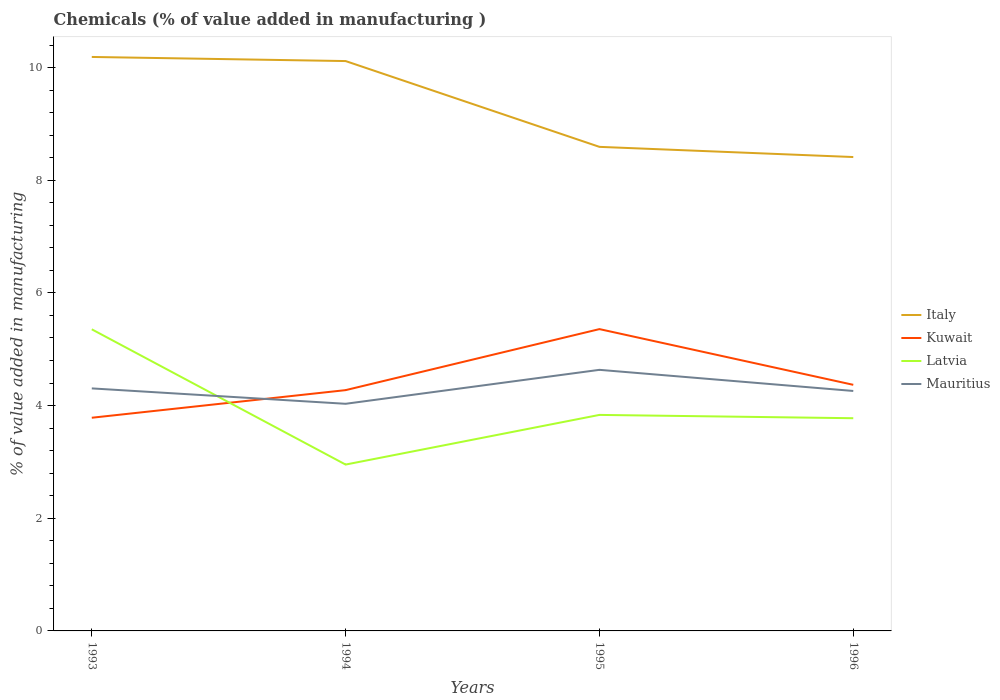Across all years, what is the maximum value added in manufacturing chemicals in Kuwait?
Give a very brief answer. 3.78. In which year was the value added in manufacturing chemicals in Mauritius maximum?
Your answer should be very brief. 1994. What is the total value added in manufacturing chemicals in Italy in the graph?
Make the answer very short. 1.78. What is the difference between the highest and the second highest value added in manufacturing chemicals in Mauritius?
Your response must be concise. 0.6. What is the difference between the highest and the lowest value added in manufacturing chemicals in Italy?
Provide a succinct answer. 2. How many lines are there?
Give a very brief answer. 4. Does the graph contain any zero values?
Give a very brief answer. No. Does the graph contain grids?
Ensure brevity in your answer.  No. How many legend labels are there?
Your response must be concise. 4. How are the legend labels stacked?
Provide a short and direct response. Vertical. What is the title of the graph?
Ensure brevity in your answer.  Chemicals (% of value added in manufacturing ). What is the label or title of the X-axis?
Keep it short and to the point. Years. What is the label or title of the Y-axis?
Your response must be concise. % of value added in manufacturing. What is the % of value added in manufacturing in Italy in 1993?
Offer a terse response. 10.19. What is the % of value added in manufacturing of Kuwait in 1993?
Make the answer very short. 3.78. What is the % of value added in manufacturing of Latvia in 1993?
Your response must be concise. 5.35. What is the % of value added in manufacturing of Mauritius in 1993?
Your response must be concise. 4.31. What is the % of value added in manufacturing of Italy in 1994?
Ensure brevity in your answer.  10.12. What is the % of value added in manufacturing in Kuwait in 1994?
Provide a short and direct response. 4.27. What is the % of value added in manufacturing of Latvia in 1994?
Give a very brief answer. 2.95. What is the % of value added in manufacturing in Mauritius in 1994?
Keep it short and to the point. 4.03. What is the % of value added in manufacturing of Italy in 1995?
Ensure brevity in your answer.  8.59. What is the % of value added in manufacturing in Kuwait in 1995?
Give a very brief answer. 5.36. What is the % of value added in manufacturing in Latvia in 1995?
Provide a short and direct response. 3.83. What is the % of value added in manufacturing of Mauritius in 1995?
Provide a succinct answer. 4.63. What is the % of value added in manufacturing in Italy in 1996?
Your response must be concise. 8.41. What is the % of value added in manufacturing in Kuwait in 1996?
Provide a short and direct response. 4.37. What is the % of value added in manufacturing of Latvia in 1996?
Give a very brief answer. 3.78. What is the % of value added in manufacturing in Mauritius in 1996?
Provide a succinct answer. 4.26. Across all years, what is the maximum % of value added in manufacturing in Italy?
Make the answer very short. 10.19. Across all years, what is the maximum % of value added in manufacturing in Kuwait?
Your response must be concise. 5.36. Across all years, what is the maximum % of value added in manufacturing of Latvia?
Offer a very short reply. 5.35. Across all years, what is the maximum % of value added in manufacturing of Mauritius?
Your answer should be very brief. 4.63. Across all years, what is the minimum % of value added in manufacturing in Italy?
Your response must be concise. 8.41. Across all years, what is the minimum % of value added in manufacturing in Kuwait?
Your answer should be compact. 3.78. Across all years, what is the minimum % of value added in manufacturing in Latvia?
Provide a succinct answer. 2.95. Across all years, what is the minimum % of value added in manufacturing of Mauritius?
Provide a short and direct response. 4.03. What is the total % of value added in manufacturing of Italy in the graph?
Offer a very short reply. 37.31. What is the total % of value added in manufacturing in Kuwait in the graph?
Make the answer very short. 17.79. What is the total % of value added in manufacturing in Latvia in the graph?
Offer a terse response. 15.92. What is the total % of value added in manufacturing of Mauritius in the graph?
Make the answer very short. 17.23. What is the difference between the % of value added in manufacturing in Italy in 1993 and that in 1994?
Make the answer very short. 0.07. What is the difference between the % of value added in manufacturing in Kuwait in 1993 and that in 1994?
Offer a terse response. -0.49. What is the difference between the % of value added in manufacturing of Latvia in 1993 and that in 1994?
Your answer should be very brief. 2.4. What is the difference between the % of value added in manufacturing in Mauritius in 1993 and that in 1994?
Make the answer very short. 0.27. What is the difference between the % of value added in manufacturing in Italy in 1993 and that in 1995?
Offer a terse response. 1.6. What is the difference between the % of value added in manufacturing of Kuwait in 1993 and that in 1995?
Your response must be concise. -1.57. What is the difference between the % of value added in manufacturing of Latvia in 1993 and that in 1995?
Provide a succinct answer. 1.52. What is the difference between the % of value added in manufacturing of Mauritius in 1993 and that in 1995?
Give a very brief answer. -0.33. What is the difference between the % of value added in manufacturing of Italy in 1993 and that in 1996?
Give a very brief answer. 1.78. What is the difference between the % of value added in manufacturing in Kuwait in 1993 and that in 1996?
Provide a succinct answer. -0.58. What is the difference between the % of value added in manufacturing of Latvia in 1993 and that in 1996?
Provide a short and direct response. 1.58. What is the difference between the % of value added in manufacturing of Mauritius in 1993 and that in 1996?
Ensure brevity in your answer.  0.05. What is the difference between the % of value added in manufacturing in Italy in 1994 and that in 1995?
Keep it short and to the point. 1.52. What is the difference between the % of value added in manufacturing in Kuwait in 1994 and that in 1995?
Provide a short and direct response. -1.08. What is the difference between the % of value added in manufacturing in Latvia in 1994 and that in 1995?
Ensure brevity in your answer.  -0.88. What is the difference between the % of value added in manufacturing of Mauritius in 1994 and that in 1995?
Offer a very short reply. -0.6. What is the difference between the % of value added in manufacturing in Italy in 1994 and that in 1996?
Give a very brief answer. 1.7. What is the difference between the % of value added in manufacturing of Kuwait in 1994 and that in 1996?
Give a very brief answer. -0.09. What is the difference between the % of value added in manufacturing in Latvia in 1994 and that in 1996?
Offer a very short reply. -0.82. What is the difference between the % of value added in manufacturing of Mauritius in 1994 and that in 1996?
Your answer should be compact. -0.23. What is the difference between the % of value added in manufacturing in Italy in 1995 and that in 1996?
Provide a short and direct response. 0.18. What is the difference between the % of value added in manufacturing of Kuwait in 1995 and that in 1996?
Provide a succinct answer. 0.99. What is the difference between the % of value added in manufacturing of Latvia in 1995 and that in 1996?
Your answer should be very brief. 0.06. What is the difference between the % of value added in manufacturing in Mauritius in 1995 and that in 1996?
Provide a short and direct response. 0.37. What is the difference between the % of value added in manufacturing in Italy in 1993 and the % of value added in manufacturing in Kuwait in 1994?
Give a very brief answer. 5.91. What is the difference between the % of value added in manufacturing in Italy in 1993 and the % of value added in manufacturing in Latvia in 1994?
Your response must be concise. 7.24. What is the difference between the % of value added in manufacturing in Italy in 1993 and the % of value added in manufacturing in Mauritius in 1994?
Ensure brevity in your answer.  6.16. What is the difference between the % of value added in manufacturing in Kuwait in 1993 and the % of value added in manufacturing in Latvia in 1994?
Offer a terse response. 0.83. What is the difference between the % of value added in manufacturing of Kuwait in 1993 and the % of value added in manufacturing of Mauritius in 1994?
Give a very brief answer. -0.25. What is the difference between the % of value added in manufacturing in Latvia in 1993 and the % of value added in manufacturing in Mauritius in 1994?
Provide a short and direct response. 1.32. What is the difference between the % of value added in manufacturing in Italy in 1993 and the % of value added in manufacturing in Kuwait in 1995?
Offer a terse response. 4.83. What is the difference between the % of value added in manufacturing in Italy in 1993 and the % of value added in manufacturing in Latvia in 1995?
Your answer should be very brief. 6.35. What is the difference between the % of value added in manufacturing of Italy in 1993 and the % of value added in manufacturing of Mauritius in 1995?
Provide a short and direct response. 5.55. What is the difference between the % of value added in manufacturing in Kuwait in 1993 and the % of value added in manufacturing in Latvia in 1995?
Keep it short and to the point. -0.05. What is the difference between the % of value added in manufacturing of Kuwait in 1993 and the % of value added in manufacturing of Mauritius in 1995?
Offer a very short reply. -0.85. What is the difference between the % of value added in manufacturing in Latvia in 1993 and the % of value added in manufacturing in Mauritius in 1995?
Your answer should be compact. 0.72. What is the difference between the % of value added in manufacturing in Italy in 1993 and the % of value added in manufacturing in Kuwait in 1996?
Give a very brief answer. 5.82. What is the difference between the % of value added in manufacturing of Italy in 1993 and the % of value added in manufacturing of Latvia in 1996?
Provide a short and direct response. 6.41. What is the difference between the % of value added in manufacturing in Italy in 1993 and the % of value added in manufacturing in Mauritius in 1996?
Keep it short and to the point. 5.93. What is the difference between the % of value added in manufacturing in Kuwait in 1993 and the % of value added in manufacturing in Latvia in 1996?
Provide a succinct answer. 0.01. What is the difference between the % of value added in manufacturing of Kuwait in 1993 and the % of value added in manufacturing of Mauritius in 1996?
Offer a terse response. -0.48. What is the difference between the % of value added in manufacturing in Latvia in 1993 and the % of value added in manufacturing in Mauritius in 1996?
Provide a succinct answer. 1.09. What is the difference between the % of value added in manufacturing of Italy in 1994 and the % of value added in manufacturing of Kuwait in 1995?
Your answer should be very brief. 4.76. What is the difference between the % of value added in manufacturing of Italy in 1994 and the % of value added in manufacturing of Latvia in 1995?
Provide a short and direct response. 6.28. What is the difference between the % of value added in manufacturing in Italy in 1994 and the % of value added in manufacturing in Mauritius in 1995?
Offer a very short reply. 5.48. What is the difference between the % of value added in manufacturing of Kuwait in 1994 and the % of value added in manufacturing of Latvia in 1995?
Ensure brevity in your answer.  0.44. What is the difference between the % of value added in manufacturing in Kuwait in 1994 and the % of value added in manufacturing in Mauritius in 1995?
Your response must be concise. -0.36. What is the difference between the % of value added in manufacturing in Latvia in 1994 and the % of value added in manufacturing in Mauritius in 1995?
Provide a succinct answer. -1.68. What is the difference between the % of value added in manufacturing in Italy in 1994 and the % of value added in manufacturing in Kuwait in 1996?
Offer a very short reply. 5.75. What is the difference between the % of value added in manufacturing in Italy in 1994 and the % of value added in manufacturing in Latvia in 1996?
Provide a succinct answer. 6.34. What is the difference between the % of value added in manufacturing in Italy in 1994 and the % of value added in manufacturing in Mauritius in 1996?
Offer a very short reply. 5.86. What is the difference between the % of value added in manufacturing in Kuwait in 1994 and the % of value added in manufacturing in Latvia in 1996?
Provide a succinct answer. 0.5. What is the difference between the % of value added in manufacturing in Kuwait in 1994 and the % of value added in manufacturing in Mauritius in 1996?
Make the answer very short. 0.01. What is the difference between the % of value added in manufacturing of Latvia in 1994 and the % of value added in manufacturing of Mauritius in 1996?
Provide a succinct answer. -1.31. What is the difference between the % of value added in manufacturing of Italy in 1995 and the % of value added in manufacturing of Kuwait in 1996?
Ensure brevity in your answer.  4.22. What is the difference between the % of value added in manufacturing in Italy in 1995 and the % of value added in manufacturing in Latvia in 1996?
Provide a succinct answer. 4.82. What is the difference between the % of value added in manufacturing of Italy in 1995 and the % of value added in manufacturing of Mauritius in 1996?
Provide a succinct answer. 4.33. What is the difference between the % of value added in manufacturing of Kuwait in 1995 and the % of value added in manufacturing of Latvia in 1996?
Your answer should be compact. 1.58. What is the difference between the % of value added in manufacturing of Kuwait in 1995 and the % of value added in manufacturing of Mauritius in 1996?
Your answer should be very brief. 1.1. What is the difference between the % of value added in manufacturing in Latvia in 1995 and the % of value added in manufacturing in Mauritius in 1996?
Keep it short and to the point. -0.42. What is the average % of value added in manufacturing of Italy per year?
Your answer should be compact. 9.33. What is the average % of value added in manufacturing of Kuwait per year?
Provide a short and direct response. 4.45. What is the average % of value added in manufacturing of Latvia per year?
Offer a terse response. 3.98. What is the average % of value added in manufacturing in Mauritius per year?
Offer a terse response. 4.31. In the year 1993, what is the difference between the % of value added in manufacturing of Italy and % of value added in manufacturing of Kuwait?
Offer a terse response. 6.4. In the year 1993, what is the difference between the % of value added in manufacturing in Italy and % of value added in manufacturing in Latvia?
Offer a very short reply. 4.83. In the year 1993, what is the difference between the % of value added in manufacturing of Italy and % of value added in manufacturing of Mauritius?
Keep it short and to the point. 5.88. In the year 1993, what is the difference between the % of value added in manufacturing in Kuwait and % of value added in manufacturing in Latvia?
Ensure brevity in your answer.  -1.57. In the year 1993, what is the difference between the % of value added in manufacturing in Kuwait and % of value added in manufacturing in Mauritius?
Your response must be concise. -0.52. In the year 1993, what is the difference between the % of value added in manufacturing of Latvia and % of value added in manufacturing of Mauritius?
Give a very brief answer. 1.05. In the year 1994, what is the difference between the % of value added in manufacturing in Italy and % of value added in manufacturing in Kuwait?
Offer a very short reply. 5.84. In the year 1994, what is the difference between the % of value added in manufacturing in Italy and % of value added in manufacturing in Latvia?
Your answer should be compact. 7.16. In the year 1994, what is the difference between the % of value added in manufacturing in Italy and % of value added in manufacturing in Mauritius?
Your response must be concise. 6.08. In the year 1994, what is the difference between the % of value added in manufacturing of Kuwait and % of value added in manufacturing of Latvia?
Provide a succinct answer. 1.32. In the year 1994, what is the difference between the % of value added in manufacturing in Kuwait and % of value added in manufacturing in Mauritius?
Provide a short and direct response. 0.24. In the year 1994, what is the difference between the % of value added in manufacturing of Latvia and % of value added in manufacturing of Mauritius?
Provide a short and direct response. -1.08. In the year 1995, what is the difference between the % of value added in manufacturing of Italy and % of value added in manufacturing of Kuwait?
Make the answer very short. 3.24. In the year 1995, what is the difference between the % of value added in manufacturing of Italy and % of value added in manufacturing of Latvia?
Ensure brevity in your answer.  4.76. In the year 1995, what is the difference between the % of value added in manufacturing of Italy and % of value added in manufacturing of Mauritius?
Keep it short and to the point. 3.96. In the year 1995, what is the difference between the % of value added in manufacturing of Kuwait and % of value added in manufacturing of Latvia?
Provide a succinct answer. 1.52. In the year 1995, what is the difference between the % of value added in manufacturing in Kuwait and % of value added in manufacturing in Mauritius?
Offer a very short reply. 0.72. In the year 1995, what is the difference between the % of value added in manufacturing of Latvia and % of value added in manufacturing of Mauritius?
Offer a terse response. -0.8. In the year 1996, what is the difference between the % of value added in manufacturing of Italy and % of value added in manufacturing of Kuwait?
Your answer should be very brief. 4.04. In the year 1996, what is the difference between the % of value added in manufacturing in Italy and % of value added in manufacturing in Latvia?
Give a very brief answer. 4.64. In the year 1996, what is the difference between the % of value added in manufacturing in Italy and % of value added in manufacturing in Mauritius?
Offer a very short reply. 4.15. In the year 1996, what is the difference between the % of value added in manufacturing of Kuwait and % of value added in manufacturing of Latvia?
Offer a terse response. 0.59. In the year 1996, what is the difference between the % of value added in manufacturing of Kuwait and % of value added in manufacturing of Mauritius?
Give a very brief answer. 0.11. In the year 1996, what is the difference between the % of value added in manufacturing of Latvia and % of value added in manufacturing of Mauritius?
Your answer should be compact. -0.48. What is the ratio of the % of value added in manufacturing in Kuwait in 1993 to that in 1994?
Your answer should be very brief. 0.89. What is the ratio of the % of value added in manufacturing of Latvia in 1993 to that in 1994?
Offer a terse response. 1.81. What is the ratio of the % of value added in manufacturing in Mauritius in 1993 to that in 1994?
Offer a terse response. 1.07. What is the ratio of the % of value added in manufacturing in Italy in 1993 to that in 1995?
Offer a very short reply. 1.19. What is the ratio of the % of value added in manufacturing of Kuwait in 1993 to that in 1995?
Ensure brevity in your answer.  0.71. What is the ratio of the % of value added in manufacturing in Latvia in 1993 to that in 1995?
Make the answer very short. 1.4. What is the ratio of the % of value added in manufacturing in Mauritius in 1993 to that in 1995?
Your answer should be very brief. 0.93. What is the ratio of the % of value added in manufacturing in Italy in 1993 to that in 1996?
Your answer should be very brief. 1.21. What is the ratio of the % of value added in manufacturing of Kuwait in 1993 to that in 1996?
Keep it short and to the point. 0.87. What is the ratio of the % of value added in manufacturing of Latvia in 1993 to that in 1996?
Make the answer very short. 1.42. What is the ratio of the % of value added in manufacturing of Mauritius in 1993 to that in 1996?
Give a very brief answer. 1.01. What is the ratio of the % of value added in manufacturing of Italy in 1994 to that in 1995?
Keep it short and to the point. 1.18. What is the ratio of the % of value added in manufacturing in Kuwait in 1994 to that in 1995?
Ensure brevity in your answer.  0.8. What is the ratio of the % of value added in manufacturing in Latvia in 1994 to that in 1995?
Ensure brevity in your answer.  0.77. What is the ratio of the % of value added in manufacturing of Mauritius in 1994 to that in 1995?
Your answer should be very brief. 0.87. What is the ratio of the % of value added in manufacturing of Italy in 1994 to that in 1996?
Provide a short and direct response. 1.2. What is the ratio of the % of value added in manufacturing in Kuwait in 1994 to that in 1996?
Provide a short and direct response. 0.98. What is the ratio of the % of value added in manufacturing of Latvia in 1994 to that in 1996?
Your answer should be very brief. 0.78. What is the ratio of the % of value added in manufacturing in Mauritius in 1994 to that in 1996?
Your answer should be compact. 0.95. What is the ratio of the % of value added in manufacturing in Italy in 1995 to that in 1996?
Make the answer very short. 1.02. What is the ratio of the % of value added in manufacturing of Kuwait in 1995 to that in 1996?
Offer a very short reply. 1.23. What is the ratio of the % of value added in manufacturing in Latvia in 1995 to that in 1996?
Keep it short and to the point. 1.02. What is the ratio of the % of value added in manufacturing in Mauritius in 1995 to that in 1996?
Your response must be concise. 1.09. What is the difference between the highest and the second highest % of value added in manufacturing in Italy?
Your response must be concise. 0.07. What is the difference between the highest and the second highest % of value added in manufacturing in Kuwait?
Your answer should be very brief. 0.99. What is the difference between the highest and the second highest % of value added in manufacturing of Latvia?
Your answer should be very brief. 1.52. What is the difference between the highest and the second highest % of value added in manufacturing of Mauritius?
Your response must be concise. 0.33. What is the difference between the highest and the lowest % of value added in manufacturing in Italy?
Give a very brief answer. 1.78. What is the difference between the highest and the lowest % of value added in manufacturing of Kuwait?
Your answer should be very brief. 1.57. What is the difference between the highest and the lowest % of value added in manufacturing in Latvia?
Your answer should be compact. 2.4. What is the difference between the highest and the lowest % of value added in manufacturing in Mauritius?
Make the answer very short. 0.6. 